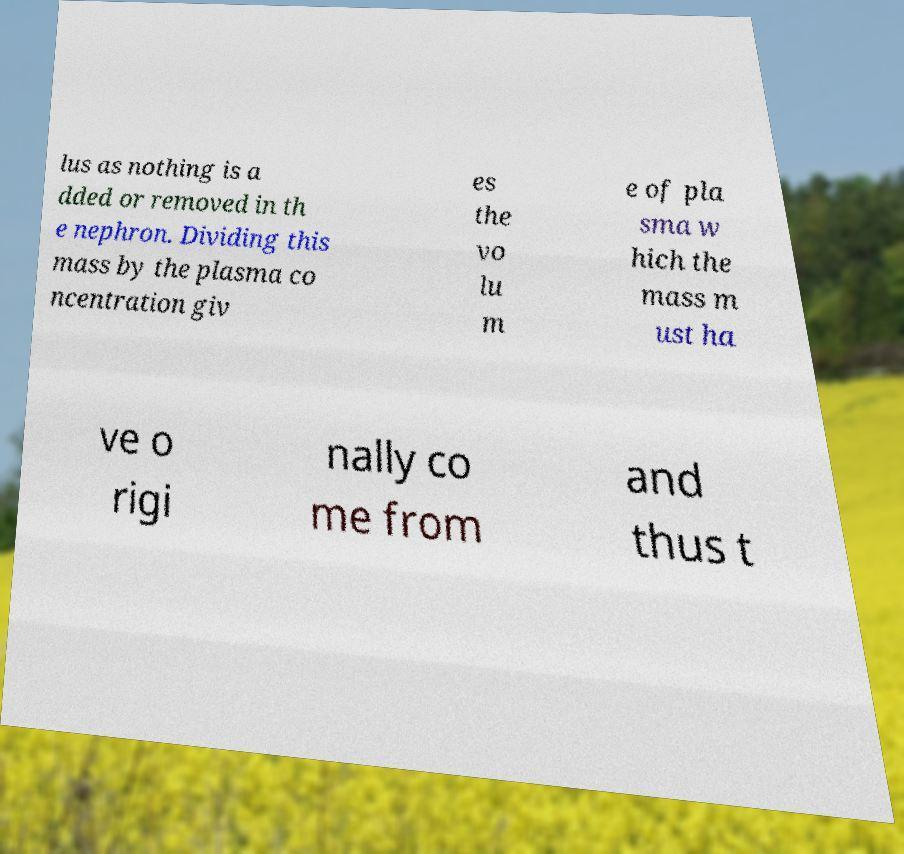Can you accurately transcribe the text from the provided image for me? lus as nothing is a dded or removed in th e nephron. Dividing this mass by the plasma co ncentration giv es the vo lu m e of pla sma w hich the mass m ust ha ve o rigi nally co me from and thus t 